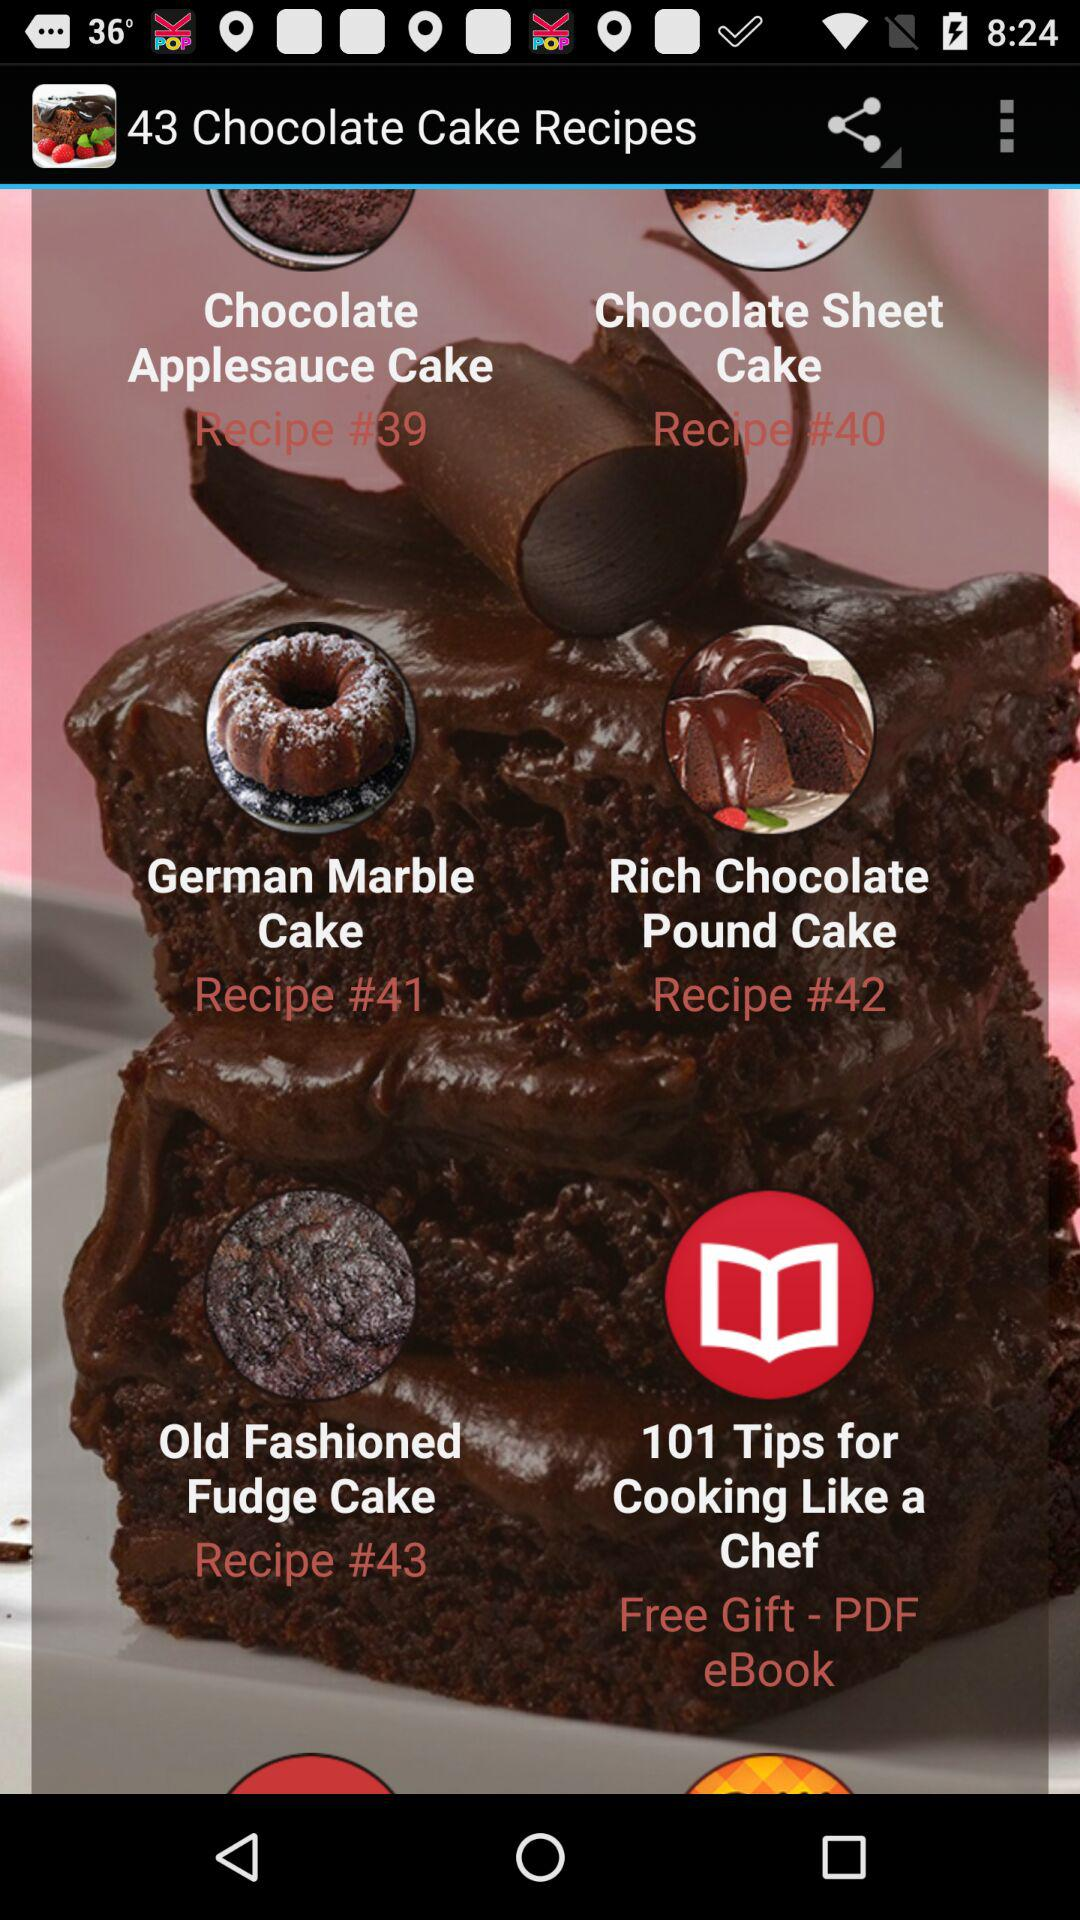What is the total number of chocolate cake recipes? The total number of chocolate cake recipes is 43. 